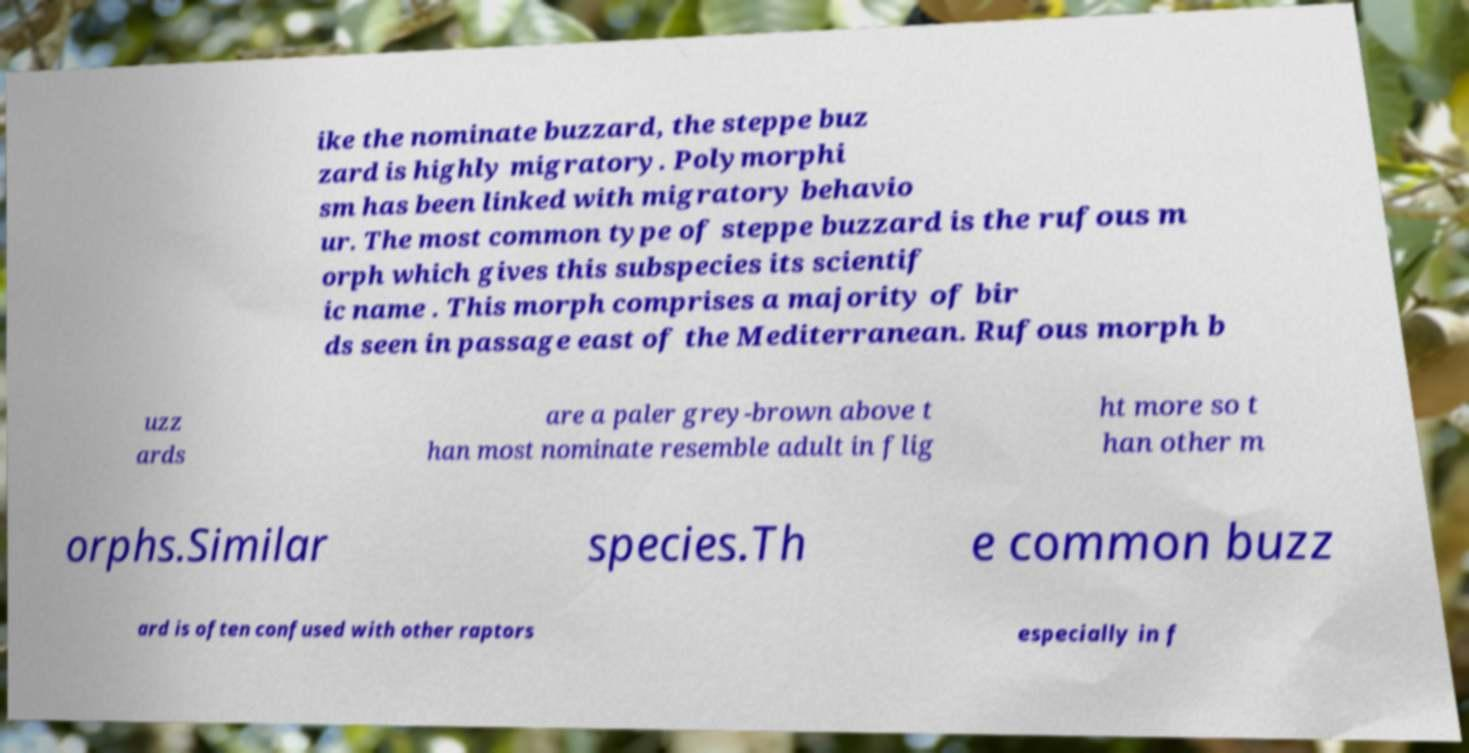Please read and relay the text visible in this image. What does it say? ike the nominate buzzard, the steppe buz zard is highly migratory. Polymorphi sm has been linked with migratory behavio ur. The most common type of steppe buzzard is the rufous m orph which gives this subspecies its scientif ic name . This morph comprises a majority of bir ds seen in passage east of the Mediterranean. Rufous morph b uzz ards are a paler grey-brown above t han most nominate resemble adult in flig ht more so t han other m orphs.Similar species.Th e common buzz ard is often confused with other raptors especially in f 